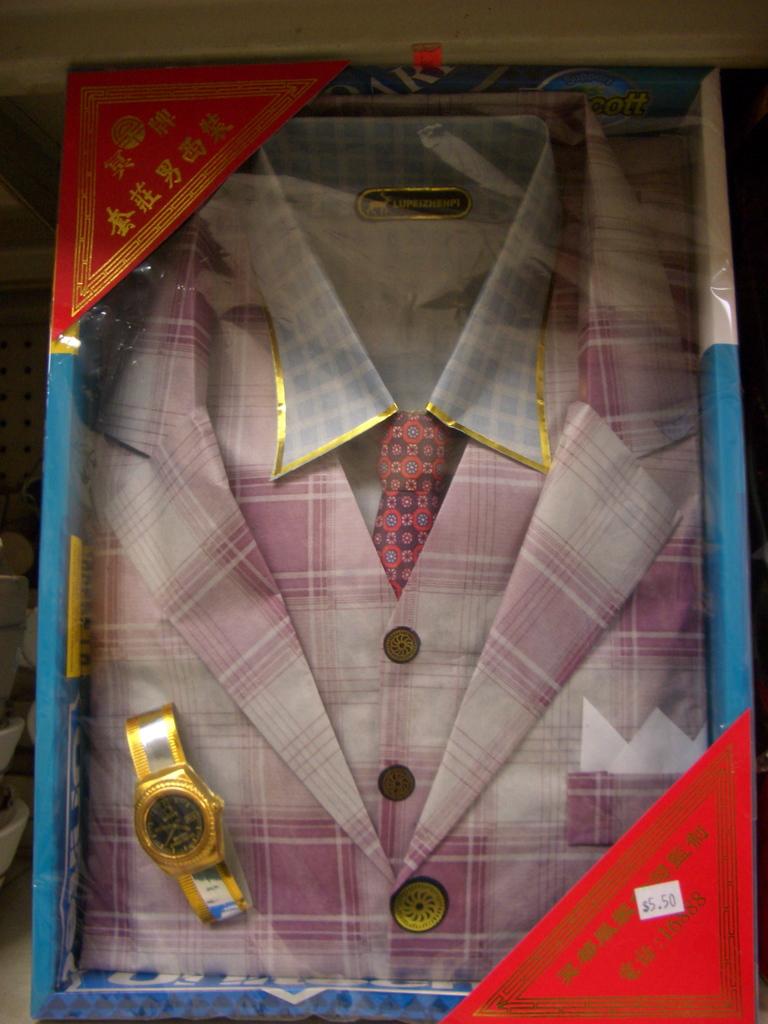Which country do you think manufactured this shirt judging by the gold text?
Your response must be concise. China. 